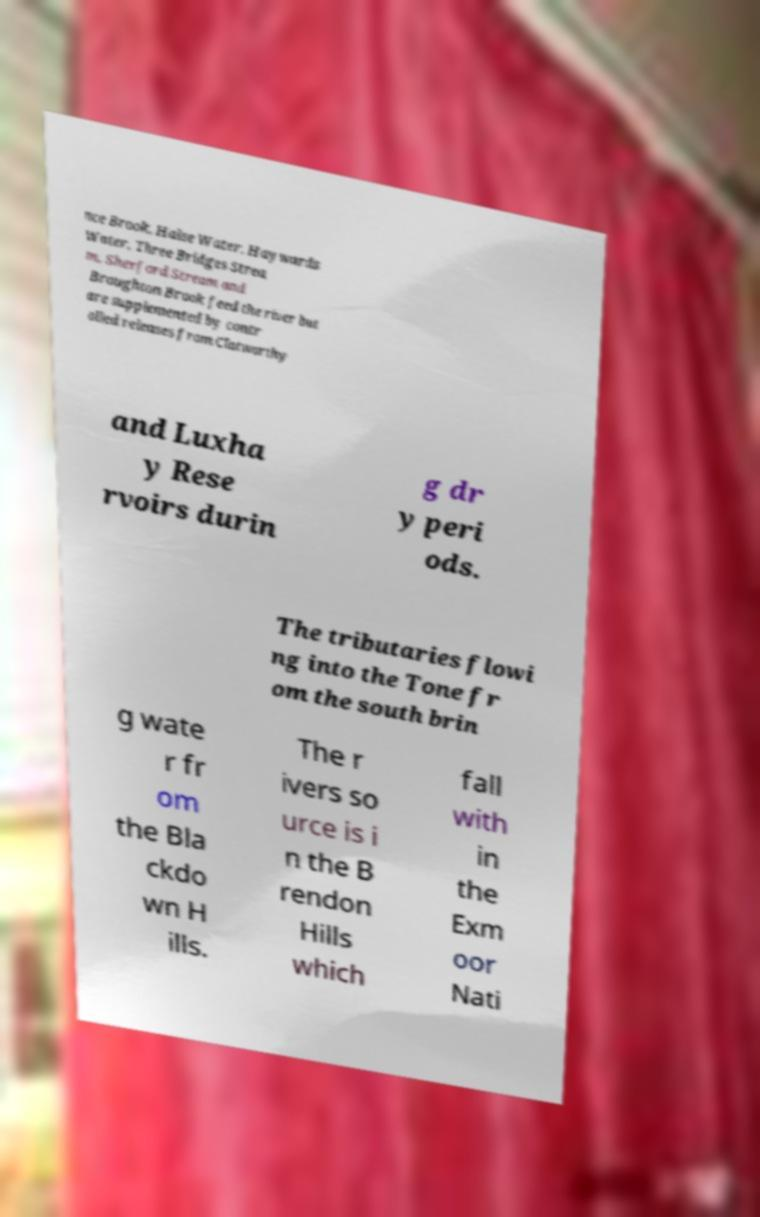Can you accurately transcribe the text from the provided image for me? nce Brook, Halse Water, Haywards Water, Three Bridges Strea m, Sherford Stream and Broughton Brook feed the river but are supplemented by contr olled releases from Clatworthy and Luxha y Rese rvoirs durin g dr y peri ods. The tributaries flowi ng into the Tone fr om the south brin g wate r fr om the Bla ckdo wn H ills. The r ivers so urce is i n the B rendon Hills which fall with in the Exm oor Nati 